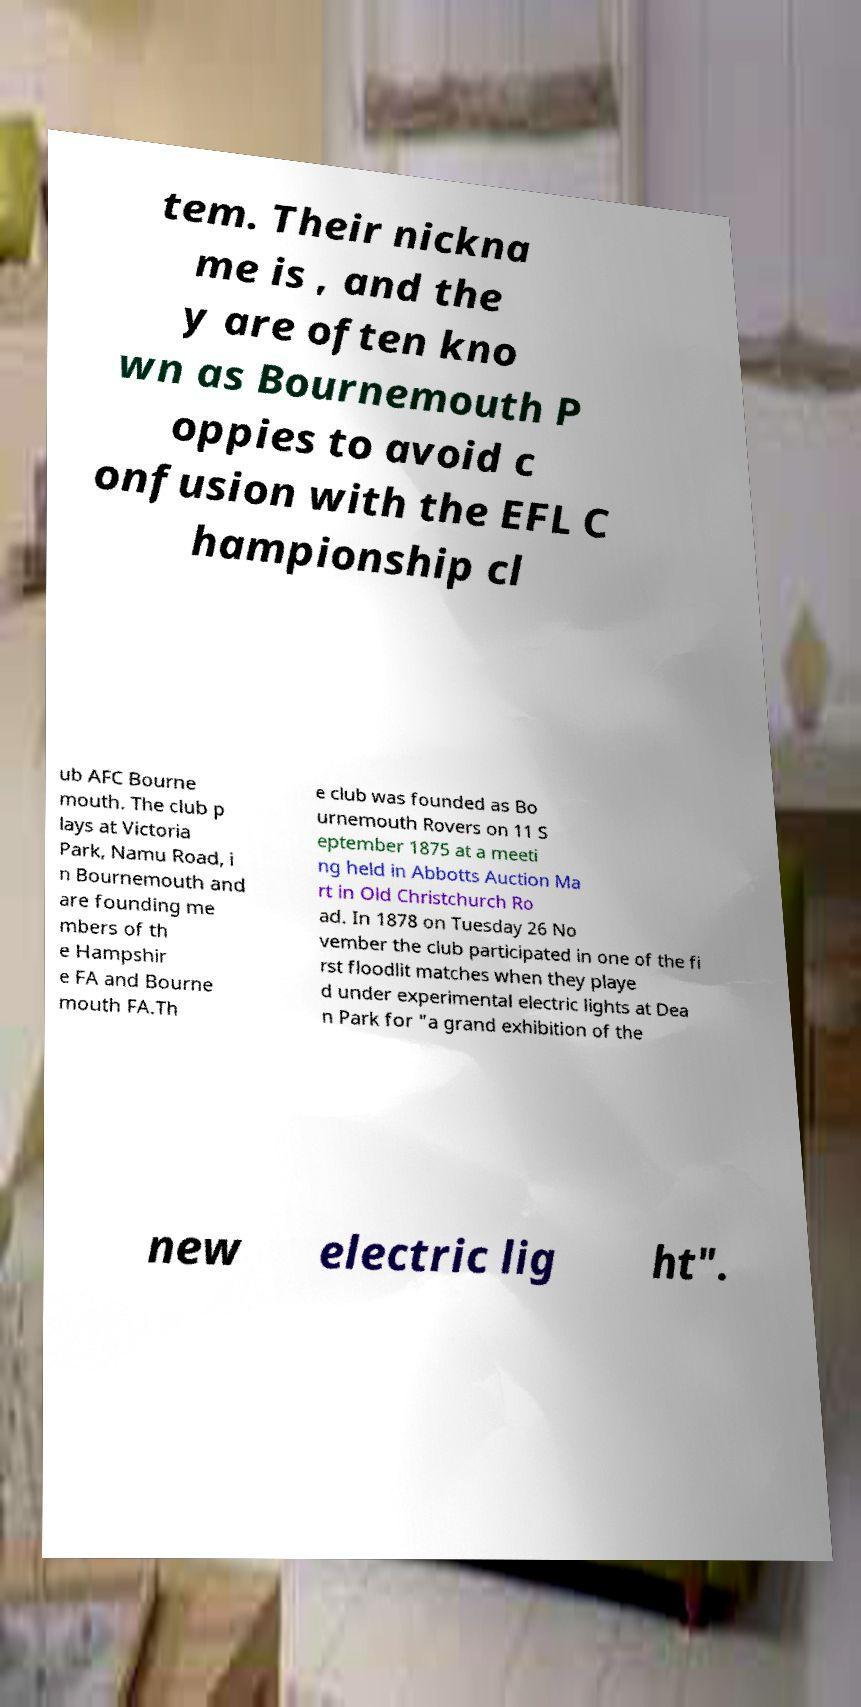Can you read and provide the text displayed in the image?This photo seems to have some interesting text. Can you extract and type it out for me? tem. Their nickna me is , and the y are often kno wn as Bournemouth P oppies to avoid c onfusion with the EFL C hampionship cl ub AFC Bourne mouth. The club p lays at Victoria Park, Namu Road, i n Bournemouth and are founding me mbers of th e Hampshir e FA and Bourne mouth FA.Th e club was founded as Bo urnemouth Rovers on 11 S eptember 1875 at a meeti ng held in Abbotts Auction Ma rt in Old Christchurch Ro ad. In 1878 on Tuesday 26 No vember the club participated in one of the fi rst floodlit matches when they playe d under experimental electric lights at Dea n Park for "a grand exhibition of the new electric lig ht". 